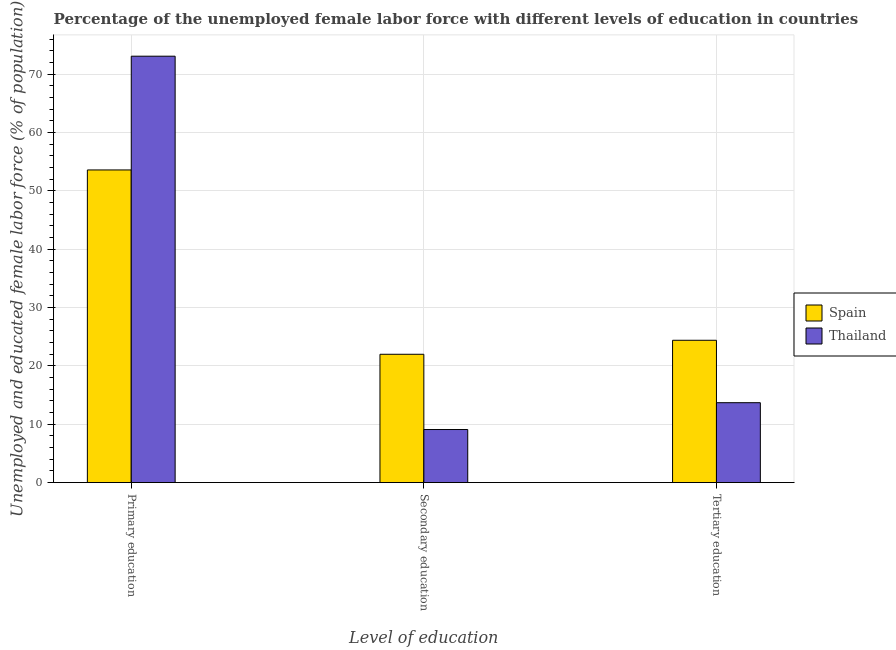How many bars are there on the 3rd tick from the left?
Your response must be concise. 2. How many bars are there on the 3rd tick from the right?
Provide a succinct answer. 2. What is the label of the 2nd group of bars from the left?
Give a very brief answer. Secondary education. What is the percentage of female labor force who received secondary education in Thailand?
Make the answer very short. 9.1. Across all countries, what is the maximum percentage of female labor force who received tertiary education?
Offer a very short reply. 24.4. Across all countries, what is the minimum percentage of female labor force who received primary education?
Your response must be concise. 53.6. In which country was the percentage of female labor force who received secondary education maximum?
Provide a short and direct response. Spain. In which country was the percentage of female labor force who received primary education minimum?
Keep it short and to the point. Spain. What is the total percentage of female labor force who received primary education in the graph?
Your response must be concise. 126.7. What is the difference between the percentage of female labor force who received tertiary education in Spain and that in Thailand?
Your answer should be very brief. 10.7. What is the difference between the percentage of female labor force who received secondary education in Spain and the percentage of female labor force who received tertiary education in Thailand?
Give a very brief answer. 8.3. What is the average percentage of female labor force who received secondary education per country?
Your answer should be very brief. 15.55. What is the difference between the percentage of female labor force who received tertiary education and percentage of female labor force who received secondary education in Spain?
Your response must be concise. 2.4. In how many countries, is the percentage of female labor force who received primary education greater than 8 %?
Provide a short and direct response. 2. What is the ratio of the percentage of female labor force who received secondary education in Thailand to that in Spain?
Ensure brevity in your answer.  0.41. What is the difference between the highest and the second highest percentage of female labor force who received secondary education?
Offer a terse response. 12.9. What is the difference between the highest and the lowest percentage of female labor force who received primary education?
Keep it short and to the point. 19.5. In how many countries, is the percentage of female labor force who received primary education greater than the average percentage of female labor force who received primary education taken over all countries?
Your answer should be compact. 1. What is the difference between two consecutive major ticks on the Y-axis?
Provide a succinct answer. 10. Are the values on the major ticks of Y-axis written in scientific E-notation?
Keep it short and to the point. No. Does the graph contain grids?
Your response must be concise. Yes. Where does the legend appear in the graph?
Make the answer very short. Center right. How many legend labels are there?
Provide a short and direct response. 2. What is the title of the graph?
Keep it short and to the point. Percentage of the unemployed female labor force with different levels of education in countries. Does "Malta" appear as one of the legend labels in the graph?
Ensure brevity in your answer.  No. What is the label or title of the X-axis?
Your response must be concise. Level of education. What is the label or title of the Y-axis?
Your answer should be very brief. Unemployed and educated female labor force (% of population). What is the Unemployed and educated female labor force (% of population) in Spain in Primary education?
Your response must be concise. 53.6. What is the Unemployed and educated female labor force (% of population) in Thailand in Primary education?
Offer a very short reply. 73.1. What is the Unemployed and educated female labor force (% of population) of Spain in Secondary education?
Provide a succinct answer. 22. What is the Unemployed and educated female labor force (% of population) in Thailand in Secondary education?
Give a very brief answer. 9.1. What is the Unemployed and educated female labor force (% of population) of Spain in Tertiary education?
Your answer should be compact. 24.4. What is the Unemployed and educated female labor force (% of population) of Thailand in Tertiary education?
Your answer should be compact. 13.7. Across all Level of education, what is the maximum Unemployed and educated female labor force (% of population) in Spain?
Offer a terse response. 53.6. Across all Level of education, what is the maximum Unemployed and educated female labor force (% of population) of Thailand?
Ensure brevity in your answer.  73.1. Across all Level of education, what is the minimum Unemployed and educated female labor force (% of population) in Spain?
Provide a succinct answer. 22. Across all Level of education, what is the minimum Unemployed and educated female labor force (% of population) in Thailand?
Provide a succinct answer. 9.1. What is the total Unemployed and educated female labor force (% of population) in Thailand in the graph?
Ensure brevity in your answer.  95.9. What is the difference between the Unemployed and educated female labor force (% of population) of Spain in Primary education and that in Secondary education?
Your response must be concise. 31.6. What is the difference between the Unemployed and educated female labor force (% of population) in Thailand in Primary education and that in Secondary education?
Provide a succinct answer. 64. What is the difference between the Unemployed and educated female labor force (% of population) of Spain in Primary education and that in Tertiary education?
Your answer should be very brief. 29.2. What is the difference between the Unemployed and educated female labor force (% of population) in Thailand in Primary education and that in Tertiary education?
Offer a terse response. 59.4. What is the difference between the Unemployed and educated female labor force (% of population) of Spain in Secondary education and that in Tertiary education?
Your answer should be very brief. -2.4. What is the difference between the Unemployed and educated female labor force (% of population) of Spain in Primary education and the Unemployed and educated female labor force (% of population) of Thailand in Secondary education?
Provide a short and direct response. 44.5. What is the difference between the Unemployed and educated female labor force (% of population) of Spain in Primary education and the Unemployed and educated female labor force (% of population) of Thailand in Tertiary education?
Provide a succinct answer. 39.9. What is the average Unemployed and educated female labor force (% of population) in Spain per Level of education?
Give a very brief answer. 33.33. What is the average Unemployed and educated female labor force (% of population) of Thailand per Level of education?
Give a very brief answer. 31.97. What is the difference between the Unemployed and educated female labor force (% of population) in Spain and Unemployed and educated female labor force (% of population) in Thailand in Primary education?
Ensure brevity in your answer.  -19.5. What is the difference between the Unemployed and educated female labor force (% of population) in Spain and Unemployed and educated female labor force (% of population) in Thailand in Secondary education?
Your answer should be compact. 12.9. What is the ratio of the Unemployed and educated female labor force (% of population) in Spain in Primary education to that in Secondary education?
Provide a succinct answer. 2.44. What is the ratio of the Unemployed and educated female labor force (% of population) of Thailand in Primary education to that in Secondary education?
Ensure brevity in your answer.  8.03. What is the ratio of the Unemployed and educated female labor force (% of population) of Spain in Primary education to that in Tertiary education?
Your answer should be compact. 2.2. What is the ratio of the Unemployed and educated female labor force (% of population) of Thailand in Primary education to that in Tertiary education?
Offer a very short reply. 5.34. What is the ratio of the Unemployed and educated female labor force (% of population) of Spain in Secondary education to that in Tertiary education?
Give a very brief answer. 0.9. What is the ratio of the Unemployed and educated female labor force (% of population) of Thailand in Secondary education to that in Tertiary education?
Keep it short and to the point. 0.66. What is the difference between the highest and the second highest Unemployed and educated female labor force (% of population) of Spain?
Ensure brevity in your answer.  29.2. What is the difference between the highest and the second highest Unemployed and educated female labor force (% of population) in Thailand?
Provide a short and direct response. 59.4. What is the difference between the highest and the lowest Unemployed and educated female labor force (% of population) of Spain?
Give a very brief answer. 31.6. 